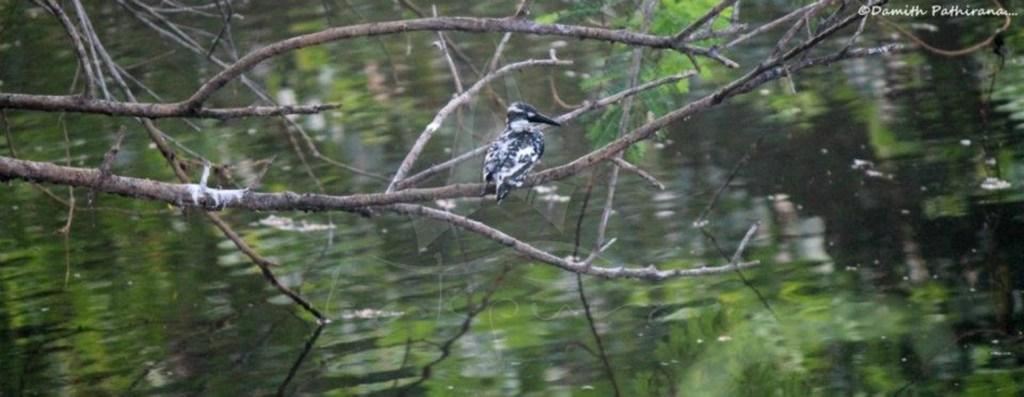What type of animal can be seen in the image? There is a bird in the image. Where is the bird located? The bird is sitting on a branch of a tree. What can be seen in the background of the image? There is water visible in the background of the image. What is present in the right top corner of the image? There is a watermark in the right top corner of the image. What type of badge is the bird wearing in the image? There is no badge present on the bird in the image. What type of pleasure does the bird seem to be experiencing in the image? The image does not convey any emotions or experiences of the bird, so it is not possible to determine the bird's pleasure. 